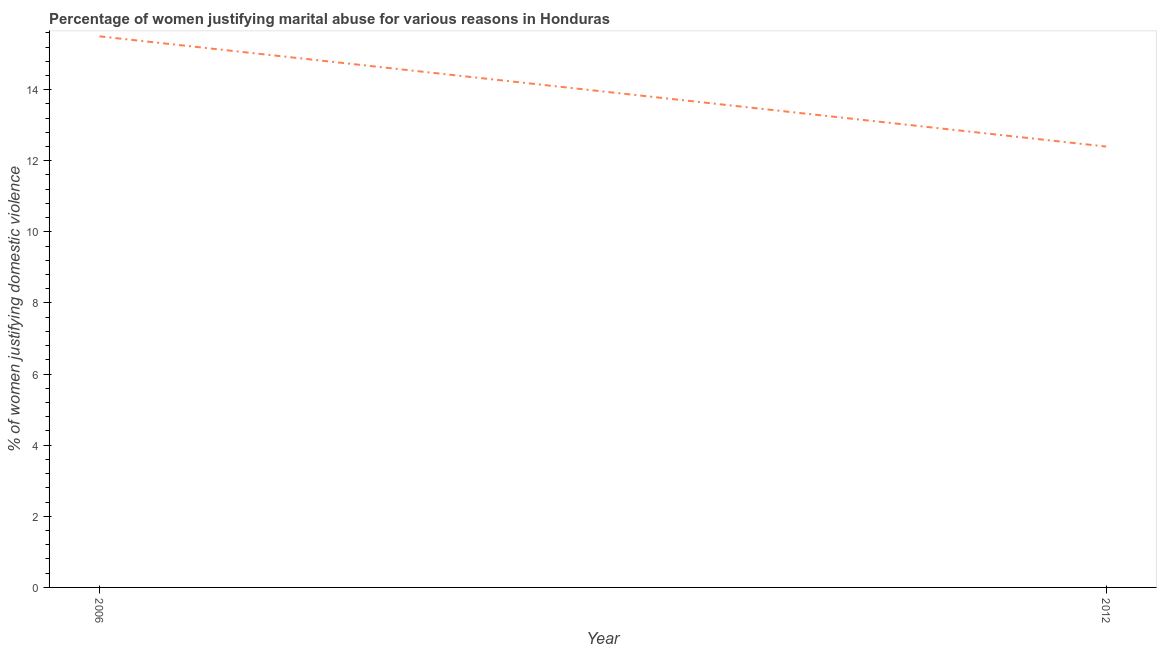What is the percentage of women justifying marital abuse in 2006?
Your answer should be compact. 15.5. Across all years, what is the maximum percentage of women justifying marital abuse?
Your answer should be very brief. 15.5. Across all years, what is the minimum percentage of women justifying marital abuse?
Offer a very short reply. 12.4. In which year was the percentage of women justifying marital abuse maximum?
Your answer should be compact. 2006. In which year was the percentage of women justifying marital abuse minimum?
Give a very brief answer. 2012. What is the sum of the percentage of women justifying marital abuse?
Make the answer very short. 27.9. What is the difference between the percentage of women justifying marital abuse in 2006 and 2012?
Your answer should be very brief. 3.1. What is the average percentage of women justifying marital abuse per year?
Provide a short and direct response. 13.95. What is the median percentage of women justifying marital abuse?
Your answer should be compact. 13.95. In how many years, is the percentage of women justifying marital abuse greater than 8.8 %?
Make the answer very short. 2. In how many years, is the percentage of women justifying marital abuse greater than the average percentage of women justifying marital abuse taken over all years?
Your answer should be very brief. 1. How many years are there in the graph?
Make the answer very short. 2. Are the values on the major ticks of Y-axis written in scientific E-notation?
Make the answer very short. No. Does the graph contain any zero values?
Make the answer very short. No. Does the graph contain grids?
Provide a succinct answer. No. What is the title of the graph?
Your response must be concise. Percentage of women justifying marital abuse for various reasons in Honduras. What is the label or title of the X-axis?
Make the answer very short. Year. What is the label or title of the Y-axis?
Your answer should be compact. % of women justifying domestic violence. What is the ratio of the % of women justifying domestic violence in 2006 to that in 2012?
Provide a succinct answer. 1.25. 